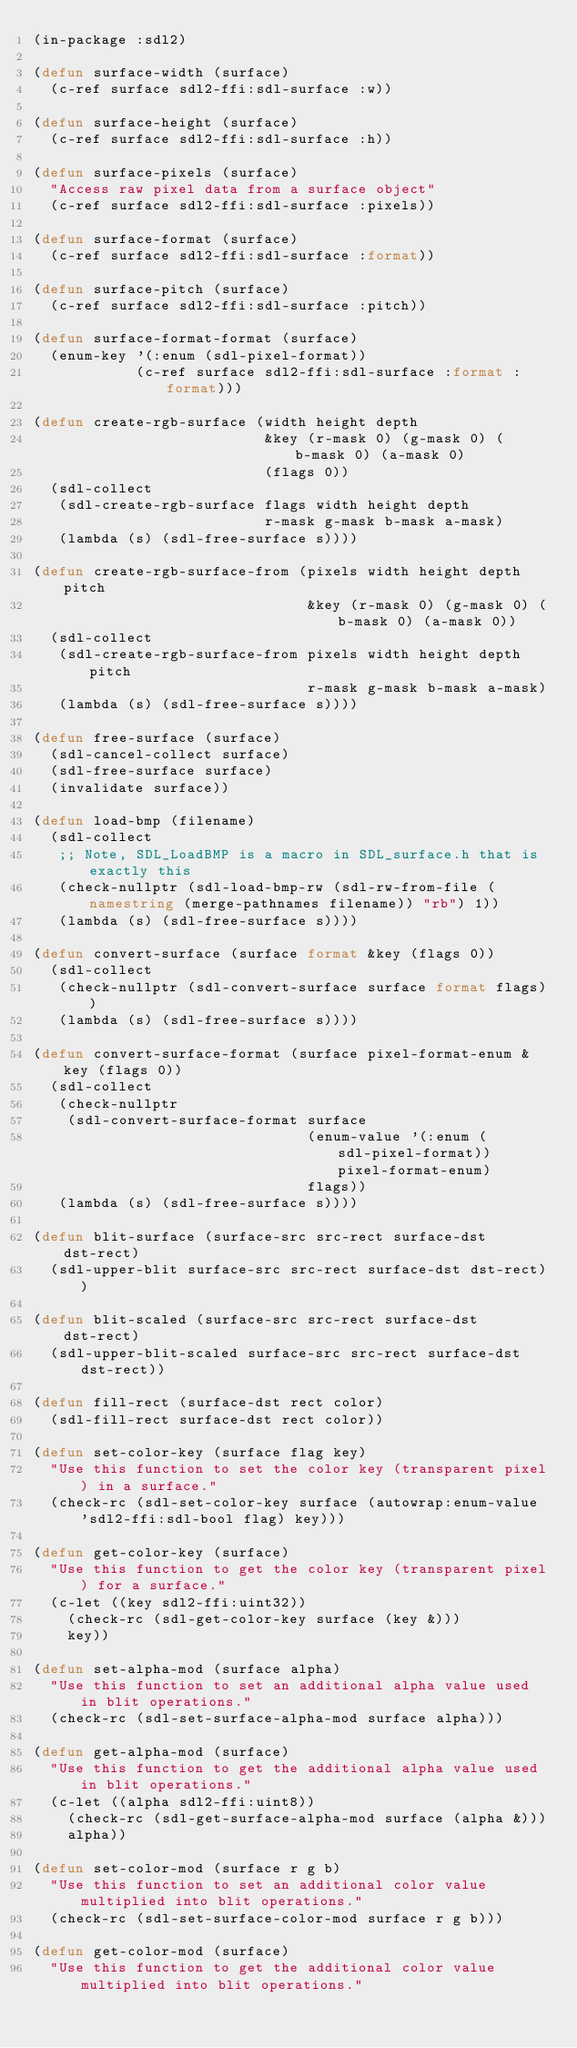Convert code to text. <code><loc_0><loc_0><loc_500><loc_500><_Lisp_>(in-package :sdl2)

(defun surface-width (surface)
  (c-ref surface sdl2-ffi:sdl-surface :w))

(defun surface-height (surface)
  (c-ref surface sdl2-ffi:sdl-surface :h))

(defun surface-pixels (surface)
  "Access raw pixel data from a surface object"
  (c-ref surface sdl2-ffi:sdl-surface :pixels))

(defun surface-format (surface)
  (c-ref surface sdl2-ffi:sdl-surface :format))

(defun surface-pitch (surface)
  (c-ref surface sdl2-ffi:sdl-surface :pitch))

(defun surface-format-format (surface)
  (enum-key '(:enum (sdl-pixel-format))
            (c-ref surface sdl2-ffi:sdl-surface :format :format)))

(defun create-rgb-surface (width height depth
                           &key (r-mask 0) (g-mask 0) (b-mask 0) (a-mask 0)
                           (flags 0))
  (sdl-collect
   (sdl-create-rgb-surface flags width height depth
                           r-mask g-mask b-mask a-mask)
   (lambda (s) (sdl-free-surface s))))

(defun create-rgb-surface-from (pixels width height depth pitch
                                &key (r-mask 0) (g-mask 0) (b-mask 0) (a-mask 0))
  (sdl-collect
   (sdl-create-rgb-surface-from pixels width height depth pitch
                                r-mask g-mask b-mask a-mask)
   (lambda (s) (sdl-free-surface s))))

(defun free-surface (surface)
  (sdl-cancel-collect surface)
  (sdl-free-surface surface)
  (invalidate surface))

(defun load-bmp (filename)
  (sdl-collect
   ;; Note, SDL_LoadBMP is a macro in SDL_surface.h that is exactly this
   (check-nullptr (sdl-load-bmp-rw (sdl-rw-from-file (namestring (merge-pathnames filename)) "rb") 1))
   (lambda (s) (sdl-free-surface s))))

(defun convert-surface (surface format &key (flags 0))
  (sdl-collect
   (check-nullptr (sdl-convert-surface surface format flags))
   (lambda (s) (sdl-free-surface s))))

(defun convert-surface-format (surface pixel-format-enum &key (flags 0))
  (sdl-collect
   (check-nullptr
    (sdl-convert-surface-format surface
                                (enum-value '(:enum (sdl-pixel-format)) pixel-format-enum)
                                flags))
   (lambda (s) (sdl-free-surface s))))

(defun blit-surface (surface-src src-rect surface-dst dst-rect)
  (sdl-upper-blit surface-src src-rect surface-dst dst-rect))

(defun blit-scaled (surface-src src-rect surface-dst dst-rect)
  (sdl-upper-blit-scaled surface-src src-rect surface-dst dst-rect))

(defun fill-rect (surface-dst rect color)
  (sdl-fill-rect surface-dst rect color))

(defun set-color-key (surface flag key)
  "Use this function to set the color key (transparent pixel) in a surface."
  (check-rc (sdl-set-color-key surface (autowrap:enum-value 'sdl2-ffi:sdl-bool flag) key)))

(defun get-color-key (surface)
  "Use this function to get the color key (transparent pixel) for a surface."
  (c-let ((key sdl2-ffi:uint32))
    (check-rc (sdl-get-color-key surface (key &)))
    key))

(defun set-alpha-mod (surface alpha)
  "Use this function to set an additional alpha value used in blit operations."
  (check-rc (sdl-set-surface-alpha-mod surface alpha)))

(defun get-alpha-mod (surface)
  "Use this function to get the additional alpha value used in blit operations."
  (c-let ((alpha sdl2-ffi:uint8))
    (check-rc (sdl-get-surface-alpha-mod surface (alpha &)))
    alpha))

(defun set-color-mod (surface r g b)
  "Use this function to set an additional color value multiplied into blit operations."
  (check-rc (sdl-set-surface-color-mod surface r g b)))

(defun get-color-mod (surface)
  "Use this function to get the additional color value multiplied into blit operations."</code> 